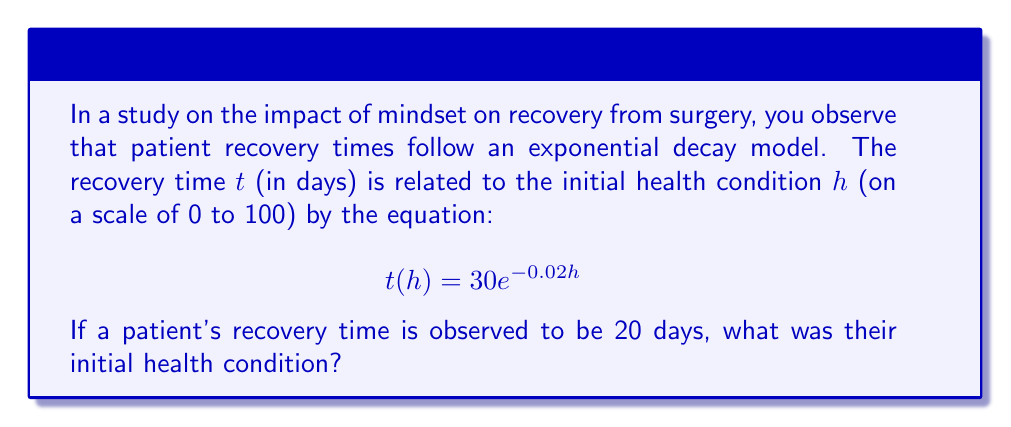What is the answer to this math problem? To solve this inverse problem, we need to determine the initial health condition (h) given the observed recovery time (t). Let's approach this step-by-step:

1. We're given the equation: $t(h) = 30e^{-0.02h}$
   And we know that $t = 20$ days

2. Substitute the known recovery time into the equation:
   $20 = 30e^{-0.02h}$

3. Divide both sides by 30:
   $\frac{20}{30} = e^{-0.02h}$
   $\frac{2}{3} = e^{-0.02h}$

4. Take the natural logarithm of both sides:
   $\ln(\frac{2}{3}) = \ln(e^{-0.02h})$
   $\ln(\frac{2}{3}) = -0.02h$

5. Divide both sides by -0.02:
   $\frac{\ln(\frac{2}{3})}{-0.02} = h$

6. Calculate the value:
   $h = \frac{\ln(0.6667)}{-0.02} \approx 20.27$

Therefore, the initial health condition was approximately 20.27 on the 0-100 scale.
Answer: $20.27$ 